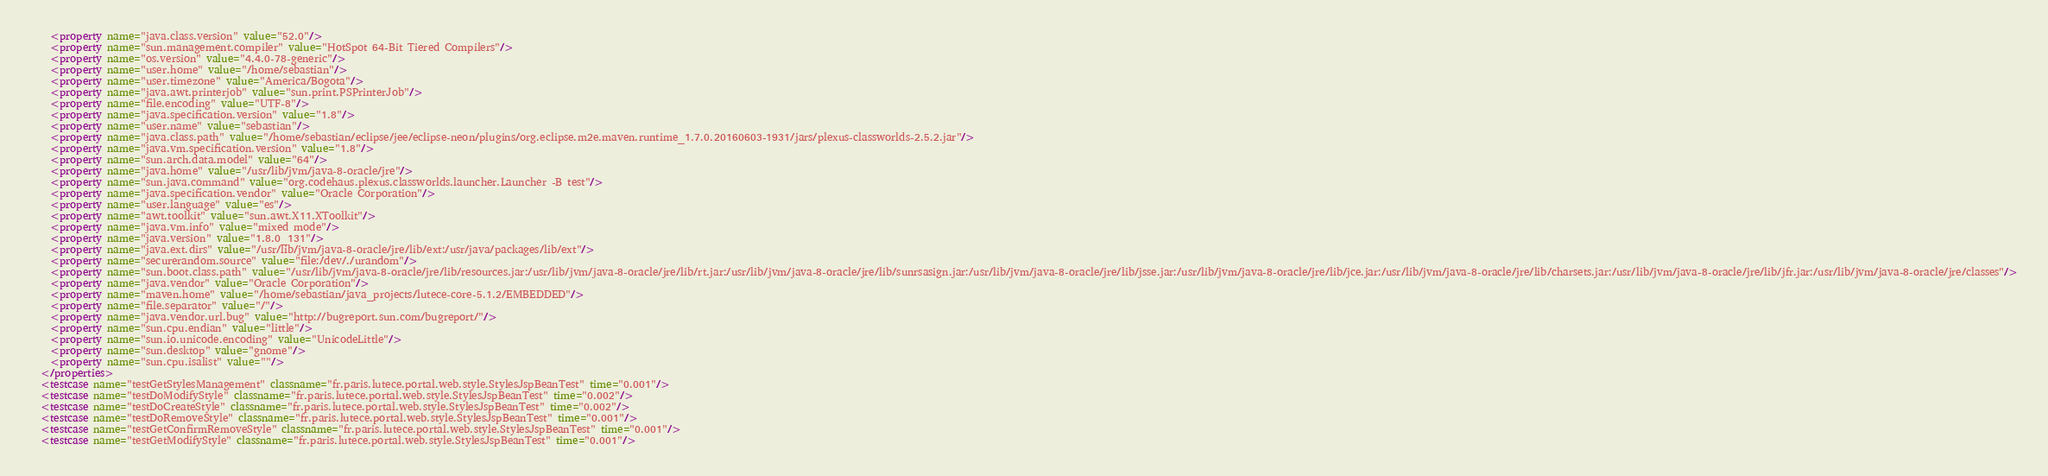<code> <loc_0><loc_0><loc_500><loc_500><_XML_>    <property name="java.class.version" value="52.0"/>
    <property name="sun.management.compiler" value="HotSpot 64-Bit Tiered Compilers"/>
    <property name="os.version" value="4.4.0-78-generic"/>
    <property name="user.home" value="/home/sebastian"/>
    <property name="user.timezone" value="America/Bogota"/>
    <property name="java.awt.printerjob" value="sun.print.PSPrinterJob"/>
    <property name="file.encoding" value="UTF-8"/>
    <property name="java.specification.version" value="1.8"/>
    <property name="user.name" value="sebastian"/>
    <property name="java.class.path" value="/home/sebastian/eclipse/jee/eclipse-neon/plugins/org.eclipse.m2e.maven.runtime_1.7.0.20160603-1931/jars/plexus-classworlds-2.5.2.jar"/>
    <property name="java.vm.specification.version" value="1.8"/>
    <property name="sun.arch.data.model" value="64"/>
    <property name="java.home" value="/usr/lib/jvm/java-8-oracle/jre"/>
    <property name="sun.java.command" value="org.codehaus.plexus.classworlds.launcher.Launcher -B test"/>
    <property name="java.specification.vendor" value="Oracle Corporation"/>
    <property name="user.language" value="es"/>
    <property name="awt.toolkit" value="sun.awt.X11.XToolkit"/>
    <property name="java.vm.info" value="mixed mode"/>
    <property name="java.version" value="1.8.0_131"/>
    <property name="java.ext.dirs" value="/usr/lib/jvm/java-8-oracle/jre/lib/ext:/usr/java/packages/lib/ext"/>
    <property name="securerandom.source" value="file:/dev/./urandom"/>
    <property name="sun.boot.class.path" value="/usr/lib/jvm/java-8-oracle/jre/lib/resources.jar:/usr/lib/jvm/java-8-oracle/jre/lib/rt.jar:/usr/lib/jvm/java-8-oracle/jre/lib/sunrsasign.jar:/usr/lib/jvm/java-8-oracle/jre/lib/jsse.jar:/usr/lib/jvm/java-8-oracle/jre/lib/jce.jar:/usr/lib/jvm/java-8-oracle/jre/lib/charsets.jar:/usr/lib/jvm/java-8-oracle/jre/lib/jfr.jar:/usr/lib/jvm/java-8-oracle/jre/classes"/>
    <property name="java.vendor" value="Oracle Corporation"/>
    <property name="maven.home" value="/home/sebastian/java_projects/lutece-core-5.1.2/EMBEDDED"/>
    <property name="file.separator" value="/"/>
    <property name="java.vendor.url.bug" value="http://bugreport.sun.com/bugreport/"/>
    <property name="sun.cpu.endian" value="little"/>
    <property name="sun.io.unicode.encoding" value="UnicodeLittle"/>
    <property name="sun.desktop" value="gnome"/>
    <property name="sun.cpu.isalist" value=""/>
  </properties>
  <testcase name="testGetStylesManagement" classname="fr.paris.lutece.portal.web.style.StylesJspBeanTest" time="0.001"/>
  <testcase name="testDoModifyStyle" classname="fr.paris.lutece.portal.web.style.StylesJspBeanTest" time="0.002"/>
  <testcase name="testDoCreateStyle" classname="fr.paris.lutece.portal.web.style.StylesJspBeanTest" time="0.002"/>
  <testcase name="testDoRemoveStyle" classname="fr.paris.lutece.portal.web.style.StylesJspBeanTest" time="0.001"/>
  <testcase name="testGetConfirmRemoveStyle" classname="fr.paris.lutece.portal.web.style.StylesJspBeanTest" time="0.001"/>
  <testcase name="testGetModifyStyle" classname="fr.paris.lutece.portal.web.style.StylesJspBeanTest" time="0.001"/></code> 